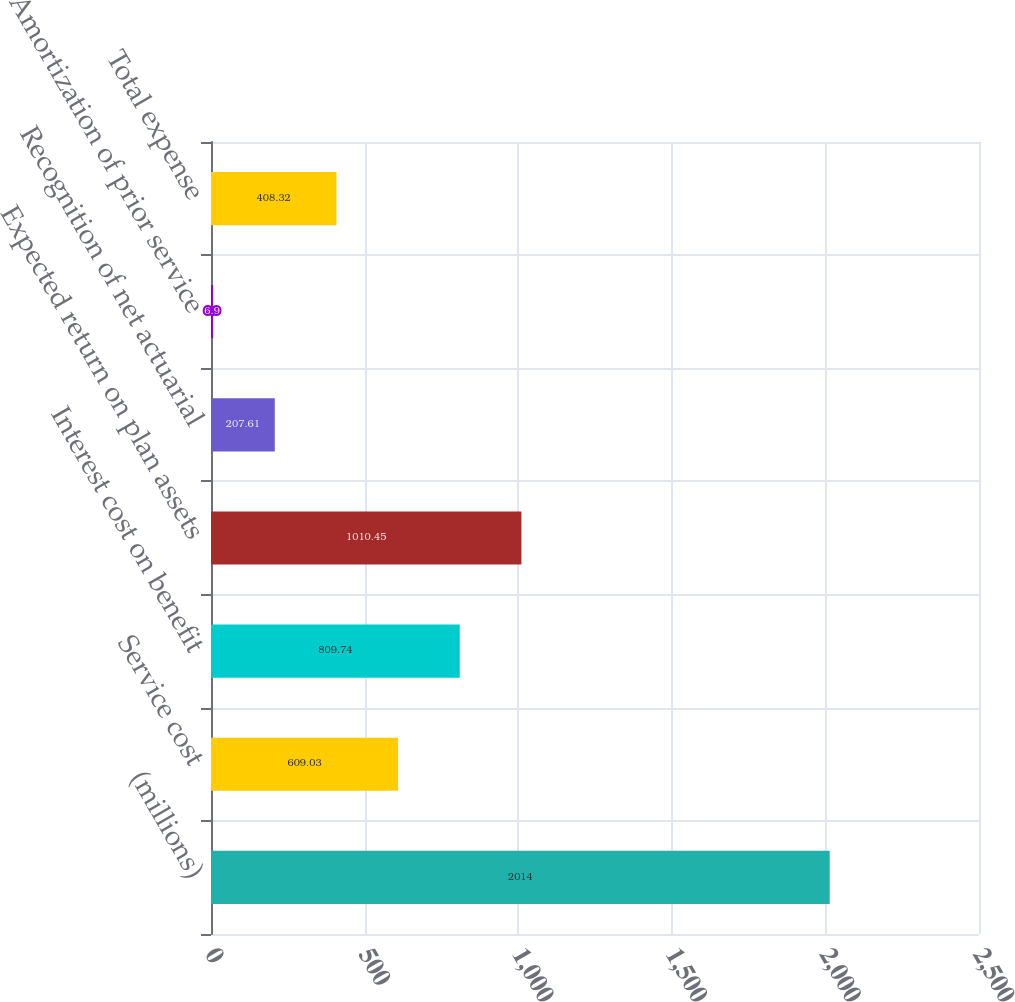Convert chart. <chart><loc_0><loc_0><loc_500><loc_500><bar_chart><fcel>(millions)<fcel>Service cost<fcel>Interest cost on benefit<fcel>Expected return on plan assets<fcel>Recognition of net actuarial<fcel>Amortization of prior service<fcel>Total expense<nl><fcel>2014<fcel>609.03<fcel>809.74<fcel>1010.45<fcel>207.61<fcel>6.9<fcel>408.32<nl></chart> 